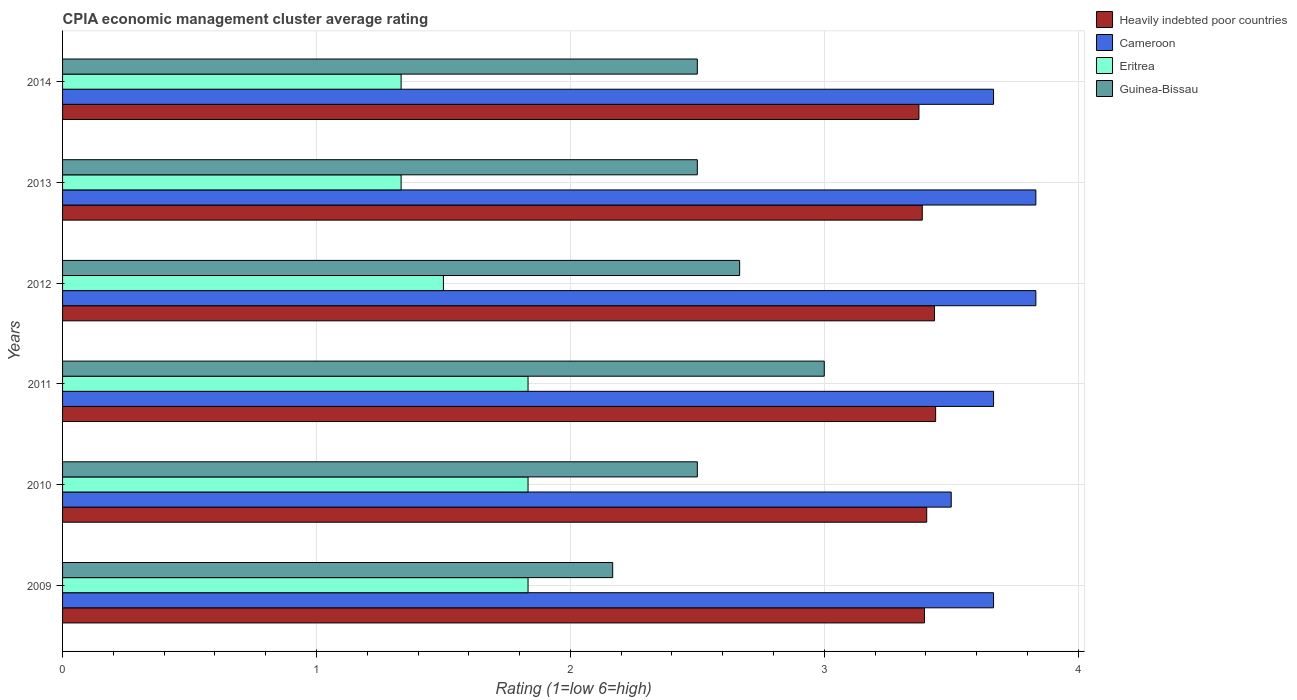How many groups of bars are there?
Provide a succinct answer. 6. How many bars are there on the 5th tick from the top?
Keep it short and to the point. 4. How many bars are there on the 5th tick from the bottom?
Keep it short and to the point. 4. What is the label of the 5th group of bars from the top?
Provide a succinct answer. 2010. In how many cases, is the number of bars for a given year not equal to the number of legend labels?
Keep it short and to the point. 0. What is the CPIA rating in Guinea-Bissau in 2010?
Make the answer very short. 2.5. Across all years, what is the maximum CPIA rating in Heavily indebted poor countries?
Ensure brevity in your answer.  3.44. Across all years, what is the minimum CPIA rating in Cameroon?
Your response must be concise. 3.5. In which year was the CPIA rating in Eritrea minimum?
Ensure brevity in your answer.  2014. What is the total CPIA rating in Cameroon in the graph?
Your answer should be compact. 22.17. What is the difference between the CPIA rating in Guinea-Bissau in 2009 and that in 2012?
Offer a terse response. -0.5. What is the difference between the CPIA rating in Cameroon in 2009 and the CPIA rating in Eritrea in 2012?
Offer a very short reply. 2.17. What is the average CPIA rating in Cameroon per year?
Your answer should be very brief. 3.69. What is the ratio of the CPIA rating in Guinea-Bissau in 2012 to that in 2013?
Provide a succinct answer. 1.07. Is the CPIA rating in Cameroon in 2012 less than that in 2013?
Your answer should be very brief. No. Is the difference between the CPIA rating in Guinea-Bissau in 2012 and 2013 greater than the difference between the CPIA rating in Cameroon in 2012 and 2013?
Offer a terse response. Yes. What is the difference between the highest and the lowest CPIA rating in Cameroon?
Offer a terse response. 0.33. Is the sum of the CPIA rating in Cameroon in 2010 and 2014 greater than the maximum CPIA rating in Heavily indebted poor countries across all years?
Provide a short and direct response. Yes. Is it the case that in every year, the sum of the CPIA rating in Cameroon and CPIA rating in Guinea-Bissau is greater than the sum of CPIA rating in Eritrea and CPIA rating in Heavily indebted poor countries?
Provide a short and direct response. No. What does the 2nd bar from the top in 2009 represents?
Keep it short and to the point. Eritrea. What does the 4th bar from the bottom in 2012 represents?
Offer a terse response. Guinea-Bissau. Is it the case that in every year, the sum of the CPIA rating in Heavily indebted poor countries and CPIA rating in Eritrea is greater than the CPIA rating in Cameroon?
Provide a short and direct response. Yes. How many bars are there?
Provide a succinct answer. 24. How many years are there in the graph?
Give a very brief answer. 6. Are the values on the major ticks of X-axis written in scientific E-notation?
Ensure brevity in your answer.  No. Does the graph contain any zero values?
Ensure brevity in your answer.  No. How are the legend labels stacked?
Your answer should be very brief. Vertical. What is the title of the graph?
Keep it short and to the point. CPIA economic management cluster average rating. What is the label or title of the X-axis?
Provide a succinct answer. Rating (1=low 6=high). What is the Rating (1=low 6=high) in Heavily indebted poor countries in 2009?
Provide a short and direct response. 3.39. What is the Rating (1=low 6=high) in Cameroon in 2009?
Offer a very short reply. 3.67. What is the Rating (1=low 6=high) in Eritrea in 2009?
Offer a terse response. 1.83. What is the Rating (1=low 6=high) in Guinea-Bissau in 2009?
Offer a terse response. 2.17. What is the Rating (1=low 6=high) in Heavily indebted poor countries in 2010?
Your response must be concise. 3.4. What is the Rating (1=low 6=high) of Cameroon in 2010?
Your response must be concise. 3.5. What is the Rating (1=low 6=high) of Eritrea in 2010?
Give a very brief answer. 1.83. What is the Rating (1=low 6=high) in Heavily indebted poor countries in 2011?
Offer a very short reply. 3.44. What is the Rating (1=low 6=high) of Cameroon in 2011?
Give a very brief answer. 3.67. What is the Rating (1=low 6=high) in Eritrea in 2011?
Your response must be concise. 1.83. What is the Rating (1=low 6=high) in Heavily indebted poor countries in 2012?
Your response must be concise. 3.43. What is the Rating (1=low 6=high) in Cameroon in 2012?
Provide a succinct answer. 3.83. What is the Rating (1=low 6=high) in Eritrea in 2012?
Provide a short and direct response. 1.5. What is the Rating (1=low 6=high) of Guinea-Bissau in 2012?
Offer a terse response. 2.67. What is the Rating (1=low 6=high) of Heavily indebted poor countries in 2013?
Make the answer very short. 3.39. What is the Rating (1=low 6=high) in Cameroon in 2013?
Ensure brevity in your answer.  3.83. What is the Rating (1=low 6=high) in Eritrea in 2013?
Offer a terse response. 1.33. What is the Rating (1=low 6=high) in Heavily indebted poor countries in 2014?
Your answer should be very brief. 3.37. What is the Rating (1=low 6=high) of Cameroon in 2014?
Give a very brief answer. 3.67. What is the Rating (1=low 6=high) in Eritrea in 2014?
Your answer should be compact. 1.33. Across all years, what is the maximum Rating (1=low 6=high) of Heavily indebted poor countries?
Your answer should be very brief. 3.44. Across all years, what is the maximum Rating (1=low 6=high) in Cameroon?
Keep it short and to the point. 3.83. Across all years, what is the maximum Rating (1=low 6=high) in Eritrea?
Give a very brief answer. 1.83. Across all years, what is the maximum Rating (1=low 6=high) in Guinea-Bissau?
Give a very brief answer. 3. Across all years, what is the minimum Rating (1=low 6=high) in Heavily indebted poor countries?
Ensure brevity in your answer.  3.37. Across all years, what is the minimum Rating (1=low 6=high) in Eritrea?
Give a very brief answer. 1.33. Across all years, what is the minimum Rating (1=low 6=high) of Guinea-Bissau?
Your answer should be very brief. 2.17. What is the total Rating (1=low 6=high) in Heavily indebted poor countries in the graph?
Give a very brief answer. 20.43. What is the total Rating (1=low 6=high) of Cameroon in the graph?
Your answer should be very brief. 22.17. What is the total Rating (1=low 6=high) in Eritrea in the graph?
Provide a short and direct response. 9.67. What is the total Rating (1=low 6=high) in Guinea-Bissau in the graph?
Your answer should be very brief. 15.33. What is the difference between the Rating (1=low 6=high) in Heavily indebted poor countries in 2009 and that in 2010?
Keep it short and to the point. -0.01. What is the difference between the Rating (1=low 6=high) in Heavily indebted poor countries in 2009 and that in 2011?
Provide a short and direct response. -0.04. What is the difference between the Rating (1=low 6=high) of Eritrea in 2009 and that in 2011?
Your answer should be very brief. 0. What is the difference between the Rating (1=low 6=high) of Heavily indebted poor countries in 2009 and that in 2012?
Give a very brief answer. -0.04. What is the difference between the Rating (1=low 6=high) of Cameroon in 2009 and that in 2012?
Provide a succinct answer. -0.17. What is the difference between the Rating (1=low 6=high) in Heavily indebted poor countries in 2009 and that in 2013?
Your response must be concise. 0.01. What is the difference between the Rating (1=low 6=high) of Cameroon in 2009 and that in 2013?
Your answer should be compact. -0.17. What is the difference between the Rating (1=low 6=high) in Guinea-Bissau in 2009 and that in 2013?
Ensure brevity in your answer.  -0.33. What is the difference between the Rating (1=low 6=high) in Heavily indebted poor countries in 2009 and that in 2014?
Offer a very short reply. 0.02. What is the difference between the Rating (1=low 6=high) in Cameroon in 2009 and that in 2014?
Your answer should be very brief. 0. What is the difference between the Rating (1=low 6=high) of Guinea-Bissau in 2009 and that in 2014?
Offer a terse response. -0.33. What is the difference between the Rating (1=low 6=high) of Heavily indebted poor countries in 2010 and that in 2011?
Make the answer very short. -0.04. What is the difference between the Rating (1=low 6=high) in Eritrea in 2010 and that in 2011?
Provide a succinct answer. 0. What is the difference between the Rating (1=low 6=high) of Guinea-Bissau in 2010 and that in 2011?
Give a very brief answer. -0.5. What is the difference between the Rating (1=low 6=high) in Heavily indebted poor countries in 2010 and that in 2012?
Offer a very short reply. -0.03. What is the difference between the Rating (1=low 6=high) of Heavily indebted poor countries in 2010 and that in 2013?
Your answer should be compact. 0.02. What is the difference between the Rating (1=low 6=high) in Guinea-Bissau in 2010 and that in 2013?
Your response must be concise. 0. What is the difference between the Rating (1=low 6=high) of Heavily indebted poor countries in 2010 and that in 2014?
Provide a succinct answer. 0.03. What is the difference between the Rating (1=low 6=high) of Cameroon in 2010 and that in 2014?
Provide a succinct answer. -0.17. What is the difference between the Rating (1=low 6=high) in Heavily indebted poor countries in 2011 and that in 2012?
Your answer should be very brief. 0. What is the difference between the Rating (1=low 6=high) in Cameroon in 2011 and that in 2012?
Give a very brief answer. -0.17. What is the difference between the Rating (1=low 6=high) in Guinea-Bissau in 2011 and that in 2012?
Offer a terse response. 0.33. What is the difference between the Rating (1=low 6=high) in Heavily indebted poor countries in 2011 and that in 2013?
Offer a very short reply. 0.05. What is the difference between the Rating (1=low 6=high) in Guinea-Bissau in 2011 and that in 2013?
Provide a short and direct response. 0.5. What is the difference between the Rating (1=low 6=high) in Heavily indebted poor countries in 2011 and that in 2014?
Make the answer very short. 0.07. What is the difference between the Rating (1=low 6=high) of Heavily indebted poor countries in 2012 and that in 2013?
Your response must be concise. 0.05. What is the difference between the Rating (1=low 6=high) in Eritrea in 2012 and that in 2013?
Keep it short and to the point. 0.17. What is the difference between the Rating (1=low 6=high) in Heavily indebted poor countries in 2012 and that in 2014?
Ensure brevity in your answer.  0.06. What is the difference between the Rating (1=low 6=high) in Cameroon in 2012 and that in 2014?
Keep it short and to the point. 0.17. What is the difference between the Rating (1=low 6=high) of Eritrea in 2012 and that in 2014?
Provide a short and direct response. 0.17. What is the difference between the Rating (1=low 6=high) of Guinea-Bissau in 2012 and that in 2014?
Offer a very short reply. 0.17. What is the difference between the Rating (1=low 6=high) of Heavily indebted poor countries in 2013 and that in 2014?
Your answer should be compact. 0.01. What is the difference between the Rating (1=low 6=high) of Cameroon in 2013 and that in 2014?
Keep it short and to the point. 0.17. What is the difference between the Rating (1=low 6=high) of Guinea-Bissau in 2013 and that in 2014?
Offer a terse response. 0. What is the difference between the Rating (1=low 6=high) of Heavily indebted poor countries in 2009 and the Rating (1=low 6=high) of Cameroon in 2010?
Provide a short and direct response. -0.11. What is the difference between the Rating (1=low 6=high) of Heavily indebted poor countries in 2009 and the Rating (1=low 6=high) of Eritrea in 2010?
Give a very brief answer. 1.56. What is the difference between the Rating (1=low 6=high) of Heavily indebted poor countries in 2009 and the Rating (1=low 6=high) of Guinea-Bissau in 2010?
Ensure brevity in your answer.  0.89. What is the difference between the Rating (1=low 6=high) of Cameroon in 2009 and the Rating (1=low 6=high) of Eritrea in 2010?
Your answer should be very brief. 1.83. What is the difference between the Rating (1=low 6=high) of Cameroon in 2009 and the Rating (1=low 6=high) of Guinea-Bissau in 2010?
Ensure brevity in your answer.  1.17. What is the difference between the Rating (1=low 6=high) of Heavily indebted poor countries in 2009 and the Rating (1=low 6=high) of Cameroon in 2011?
Make the answer very short. -0.27. What is the difference between the Rating (1=low 6=high) in Heavily indebted poor countries in 2009 and the Rating (1=low 6=high) in Eritrea in 2011?
Offer a terse response. 1.56. What is the difference between the Rating (1=low 6=high) of Heavily indebted poor countries in 2009 and the Rating (1=low 6=high) of Guinea-Bissau in 2011?
Keep it short and to the point. 0.39. What is the difference between the Rating (1=low 6=high) of Cameroon in 2009 and the Rating (1=low 6=high) of Eritrea in 2011?
Ensure brevity in your answer.  1.83. What is the difference between the Rating (1=low 6=high) of Eritrea in 2009 and the Rating (1=low 6=high) of Guinea-Bissau in 2011?
Keep it short and to the point. -1.17. What is the difference between the Rating (1=low 6=high) of Heavily indebted poor countries in 2009 and the Rating (1=low 6=high) of Cameroon in 2012?
Provide a short and direct response. -0.44. What is the difference between the Rating (1=low 6=high) in Heavily indebted poor countries in 2009 and the Rating (1=low 6=high) in Eritrea in 2012?
Your answer should be compact. 1.89. What is the difference between the Rating (1=low 6=high) of Heavily indebted poor countries in 2009 and the Rating (1=low 6=high) of Guinea-Bissau in 2012?
Provide a short and direct response. 0.73. What is the difference between the Rating (1=low 6=high) in Cameroon in 2009 and the Rating (1=low 6=high) in Eritrea in 2012?
Ensure brevity in your answer.  2.17. What is the difference between the Rating (1=low 6=high) of Eritrea in 2009 and the Rating (1=low 6=high) of Guinea-Bissau in 2012?
Your answer should be compact. -0.83. What is the difference between the Rating (1=low 6=high) of Heavily indebted poor countries in 2009 and the Rating (1=low 6=high) of Cameroon in 2013?
Your response must be concise. -0.44. What is the difference between the Rating (1=low 6=high) of Heavily indebted poor countries in 2009 and the Rating (1=low 6=high) of Eritrea in 2013?
Make the answer very short. 2.06. What is the difference between the Rating (1=low 6=high) in Heavily indebted poor countries in 2009 and the Rating (1=low 6=high) in Guinea-Bissau in 2013?
Make the answer very short. 0.89. What is the difference between the Rating (1=low 6=high) in Cameroon in 2009 and the Rating (1=low 6=high) in Eritrea in 2013?
Provide a succinct answer. 2.33. What is the difference between the Rating (1=low 6=high) in Eritrea in 2009 and the Rating (1=low 6=high) in Guinea-Bissau in 2013?
Provide a succinct answer. -0.67. What is the difference between the Rating (1=low 6=high) of Heavily indebted poor countries in 2009 and the Rating (1=low 6=high) of Cameroon in 2014?
Provide a short and direct response. -0.27. What is the difference between the Rating (1=low 6=high) of Heavily indebted poor countries in 2009 and the Rating (1=low 6=high) of Eritrea in 2014?
Make the answer very short. 2.06. What is the difference between the Rating (1=low 6=high) of Heavily indebted poor countries in 2009 and the Rating (1=low 6=high) of Guinea-Bissau in 2014?
Give a very brief answer. 0.89. What is the difference between the Rating (1=low 6=high) in Cameroon in 2009 and the Rating (1=low 6=high) in Eritrea in 2014?
Provide a short and direct response. 2.33. What is the difference between the Rating (1=low 6=high) in Eritrea in 2009 and the Rating (1=low 6=high) in Guinea-Bissau in 2014?
Ensure brevity in your answer.  -0.67. What is the difference between the Rating (1=low 6=high) in Heavily indebted poor countries in 2010 and the Rating (1=low 6=high) in Cameroon in 2011?
Offer a very short reply. -0.26. What is the difference between the Rating (1=low 6=high) in Heavily indebted poor countries in 2010 and the Rating (1=low 6=high) in Eritrea in 2011?
Offer a very short reply. 1.57. What is the difference between the Rating (1=low 6=high) in Heavily indebted poor countries in 2010 and the Rating (1=low 6=high) in Guinea-Bissau in 2011?
Offer a very short reply. 0.4. What is the difference between the Rating (1=low 6=high) of Cameroon in 2010 and the Rating (1=low 6=high) of Guinea-Bissau in 2011?
Give a very brief answer. 0.5. What is the difference between the Rating (1=low 6=high) of Eritrea in 2010 and the Rating (1=low 6=high) of Guinea-Bissau in 2011?
Ensure brevity in your answer.  -1.17. What is the difference between the Rating (1=low 6=high) in Heavily indebted poor countries in 2010 and the Rating (1=low 6=high) in Cameroon in 2012?
Your response must be concise. -0.43. What is the difference between the Rating (1=low 6=high) in Heavily indebted poor countries in 2010 and the Rating (1=low 6=high) in Eritrea in 2012?
Provide a short and direct response. 1.9. What is the difference between the Rating (1=low 6=high) of Heavily indebted poor countries in 2010 and the Rating (1=low 6=high) of Guinea-Bissau in 2012?
Keep it short and to the point. 0.74. What is the difference between the Rating (1=low 6=high) in Eritrea in 2010 and the Rating (1=low 6=high) in Guinea-Bissau in 2012?
Give a very brief answer. -0.83. What is the difference between the Rating (1=low 6=high) of Heavily indebted poor countries in 2010 and the Rating (1=low 6=high) of Cameroon in 2013?
Provide a succinct answer. -0.43. What is the difference between the Rating (1=low 6=high) of Heavily indebted poor countries in 2010 and the Rating (1=low 6=high) of Eritrea in 2013?
Your answer should be compact. 2.07. What is the difference between the Rating (1=low 6=high) in Heavily indebted poor countries in 2010 and the Rating (1=low 6=high) in Guinea-Bissau in 2013?
Your answer should be very brief. 0.9. What is the difference between the Rating (1=low 6=high) of Cameroon in 2010 and the Rating (1=low 6=high) of Eritrea in 2013?
Your response must be concise. 2.17. What is the difference between the Rating (1=low 6=high) in Cameroon in 2010 and the Rating (1=low 6=high) in Guinea-Bissau in 2013?
Your answer should be compact. 1. What is the difference between the Rating (1=low 6=high) of Heavily indebted poor countries in 2010 and the Rating (1=low 6=high) of Cameroon in 2014?
Keep it short and to the point. -0.26. What is the difference between the Rating (1=low 6=high) of Heavily indebted poor countries in 2010 and the Rating (1=low 6=high) of Eritrea in 2014?
Offer a terse response. 2.07. What is the difference between the Rating (1=low 6=high) in Heavily indebted poor countries in 2010 and the Rating (1=low 6=high) in Guinea-Bissau in 2014?
Keep it short and to the point. 0.9. What is the difference between the Rating (1=low 6=high) of Cameroon in 2010 and the Rating (1=low 6=high) of Eritrea in 2014?
Offer a terse response. 2.17. What is the difference between the Rating (1=low 6=high) in Eritrea in 2010 and the Rating (1=low 6=high) in Guinea-Bissau in 2014?
Give a very brief answer. -0.67. What is the difference between the Rating (1=low 6=high) of Heavily indebted poor countries in 2011 and the Rating (1=low 6=high) of Cameroon in 2012?
Your answer should be very brief. -0.39. What is the difference between the Rating (1=low 6=high) of Heavily indebted poor countries in 2011 and the Rating (1=low 6=high) of Eritrea in 2012?
Give a very brief answer. 1.94. What is the difference between the Rating (1=low 6=high) in Heavily indebted poor countries in 2011 and the Rating (1=low 6=high) in Guinea-Bissau in 2012?
Offer a terse response. 0.77. What is the difference between the Rating (1=low 6=high) in Cameroon in 2011 and the Rating (1=low 6=high) in Eritrea in 2012?
Your response must be concise. 2.17. What is the difference between the Rating (1=low 6=high) in Eritrea in 2011 and the Rating (1=low 6=high) in Guinea-Bissau in 2012?
Your response must be concise. -0.83. What is the difference between the Rating (1=low 6=high) of Heavily indebted poor countries in 2011 and the Rating (1=low 6=high) of Cameroon in 2013?
Your answer should be very brief. -0.39. What is the difference between the Rating (1=low 6=high) in Heavily indebted poor countries in 2011 and the Rating (1=low 6=high) in Eritrea in 2013?
Offer a very short reply. 2.11. What is the difference between the Rating (1=low 6=high) in Heavily indebted poor countries in 2011 and the Rating (1=low 6=high) in Guinea-Bissau in 2013?
Provide a short and direct response. 0.94. What is the difference between the Rating (1=low 6=high) of Cameroon in 2011 and the Rating (1=low 6=high) of Eritrea in 2013?
Keep it short and to the point. 2.33. What is the difference between the Rating (1=low 6=high) in Cameroon in 2011 and the Rating (1=low 6=high) in Guinea-Bissau in 2013?
Offer a terse response. 1.17. What is the difference between the Rating (1=low 6=high) in Eritrea in 2011 and the Rating (1=low 6=high) in Guinea-Bissau in 2013?
Give a very brief answer. -0.67. What is the difference between the Rating (1=low 6=high) in Heavily indebted poor countries in 2011 and the Rating (1=low 6=high) in Cameroon in 2014?
Provide a succinct answer. -0.23. What is the difference between the Rating (1=low 6=high) of Heavily indebted poor countries in 2011 and the Rating (1=low 6=high) of Eritrea in 2014?
Make the answer very short. 2.11. What is the difference between the Rating (1=low 6=high) in Heavily indebted poor countries in 2011 and the Rating (1=low 6=high) in Guinea-Bissau in 2014?
Provide a short and direct response. 0.94. What is the difference between the Rating (1=low 6=high) of Cameroon in 2011 and the Rating (1=low 6=high) of Eritrea in 2014?
Your answer should be very brief. 2.33. What is the difference between the Rating (1=low 6=high) in Heavily indebted poor countries in 2012 and the Rating (1=low 6=high) in Cameroon in 2013?
Your answer should be compact. -0.4. What is the difference between the Rating (1=low 6=high) in Heavily indebted poor countries in 2012 and the Rating (1=low 6=high) in Eritrea in 2013?
Your response must be concise. 2.1. What is the difference between the Rating (1=low 6=high) in Heavily indebted poor countries in 2012 and the Rating (1=low 6=high) in Guinea-Bissau in 2013?
Offer a terse response. 0.93. What is the difference between the Rating (1=low 6=high) of Cameroon in 2012 and the Rating (1=low 6=high) of Eritrea in 2013?
Provide a succinct answer. 2.5. What is the difference between the Rating (1=low 6=high) of Cameroon in 2012 and the Rating (1=low 6=high) of Guinea-Bissau in 2013?
Give a very brief answer. 1.33. What is the difference between the Rating (1=low 6=high) of Heavily indebted poor countries in 2012 and the Rating (1=low 6=high) of Cameroon in 2014?
Offer a terse response. -0.23. What is the difference between the Rating (1=low 6=high) of Heavily indebted poor countries in 2012 and the Rating (1=low 6=high) of Eritrea in 2014?
Offer a very short reply. 2.1. What is the difference between the Rating (1=low 6=high) of Heavily indebted poor countries in 2012 and the Rating (1=low 6=high) of Guinea-Bissau in 2014?
Provide a succinct answer. 0.93. What is the difference between the Rating (1=low 6=high) of Eritrea in 2012 and the Rating (1=low 6=high) of Guinea-Bissau in 2014?
Give a very brief answer. -1. What is the difference between the Rating (1=low 6=high) in Heavily indebted poor countries in 2013 and the Rating (1=low 6=high) in Cameroon in 2014?
Provide a succinct answer. -0.28. What is the difference between the Rating (1=low 6=high) of Heavily indebted poor countries in 2013 and the Rating (1=low 6=high) of Eritrea in 2014?
Provide a short and direct response. 2.05. What is the difference between the Rating (1=low 6=high) in Heavily indebted poor countries in 2013 and the Rating (1=low 6=high) in Guinea-Bissau in 2014?
Provide a succinct answer. 0.89. What is the difference between the Rating (1=low 6=high) in Cameroon in 2013 and the Rating (1=low 6=high) in Guinea-Bissau in 2014?
Your answer should be compact. 1.33. What is the difference between the Rating (1=low 6=high) in Eritrea in 2013 and the Rating (1=low 6=high) in Guinea-Bissau in 2014?
Give a very brief answer. -1.17. What is the average Rating (1=low 6=high) of Heavily indebted poor countries per year?
Your answer should be compact. 3.4. What is the average Rating (1=low 6=high) of Cameroon per year?
Keep it short and to the point. 3.69. What is the average Rating (1=low 6=high) in Eritrea per year?
Keep it short and to the point. 1.61. What is the average Rating (1=low 6=high) in Guinea-Bissau per year?
Provide a succinct answer. 2.56. In the year 2009, what is the difference between the Rating (1=low 6=high) of Heavily indebted poor countries and Rating (1=low 6=high) of Cameroon?
Offer a terse response. -0.27. In the year 2009, what is the difference between the Rating (1=low 6=high) of Heavily indebted poor countries and Rating (1=low 6=high) of Eritrea?
Your answer should be very brief. 1.56. In the year 2009, what is the difference between the Rating (1=low 6=high) in Heavily indebted poor countries and Rating (1=low 6=high) in Guinea-Bissau?
Provide a succinct answer. 1.23. In the year 2009, what is the difference between the Rating (1=low 6=high) of Cameroon and Rating (1=low 6=high) of Eritrea?
Your answer should be very brief. 1.83. In the year 2009, what is the difference between the Rating (1=low 6=high) of Eritrea and Rating (1=low 6=high) of Guinea-Bissau?
Offer a terse response. -0.33. In the year 2010, what is the difference between the Rating (1=low 6=high) in Heavily indebted poor countries and Rating (1=low 6=high) in Cameroon?
Your answer should be very brief. -0.1. In the year 2010, what is the difference between the Rating (1=low 6=high) in Heavily indebted poor countries and Rating (1=low 6=high) in Eritrea?
Your answer should be very brief. 1.57. In the year 2010, what is the difference between the Rating (1=low 6=high) of Heavily indebted poor countries and Rating (1=low 6=high) of Guinea-Bissau?
Make the answer very short. 0.9. In the year 2010, what is the difference between the Rating (1=low 6=high) of Cameroon and Rating (1=low 6=high) of Guinea-Bissau?
Offer a very short reply. 1. In the year 2010, what is the difference between the Rating (1=low 6=high) in Eritrea and Rating (1=low 6=high) in Guinea-Bissau?
Your answer should be compact. -0.67. In the year 2011, what is the difference between the Rating (1=low 6=high) in Heavily indebted poor countries and Rating (1=low 6=high) in Cameroon?
Make the answer very short. -0.23. In the year 2011, what is the difference between the Rating (1=low 6=high) of Heavily indebted poor countries and Rating (1=low 6=high) of Eritrea?
Keep it short and to the point. 1.61. In the year 2011, what is the difference between the Rating (1=low 6=high) of Heavily indebted poor countries and Rating (1=low 6=high) of Guinea-Bissau?
Provide a succinct answer. 0.44. In the year 2011, what is the difference between the Rating (1=low 6=high) in Cameroon and Rating (1=low 6=high) in Eritrea?
Offer a terse response. 1.83. In the year 2011, what is the difference between the Rating (1=low 6=high) of Eritrea and Rating (1=low 6=high) of Guinea-Bissau?
Keep it short and to the point. -1.17. In the year 2012, what is the difference between the Rating (1=low 6=high) in Heavily indebted poor countries and Rating (1=low 6=high) in Cameroon?
Ensure brevity in your answer.  -0.4. In the year 2012, what is the difference between the Rating (1=low 6=high) of Heavily indebted poor countries and Rating (1=low 6=high) of Eritrea?
Keep it short and to the point. 1.93. In the year 2012, what is the difference between the Rating (1=low 6=high) in Heavily indebted poor countries and Rating (1=low 6=high) in Guinea-Bissau?
Give a very brief answer. 0.77. In the year 2012, what is the difference between the Rating (1=low 6=high) of Cameroon and Rating (1=low 6=high) of Eritrea?
Ensure brevity in your answer.  2.33. In the year 2012, what is the difference between the Rating (1=low 6=high) in Cameroon and Rating (1=low 6=high) in Guinea-Bissau?
Provide a short and direct response. 1.17. In the year 2012, what is the difference between the Rating (1=low 6=high) in Eritrea and Rating (1=low 6=high) in Guinea-Bissau?
Your answer should be compact. -1.17. In the year 2013, what is the difference between the Rating (1=low 6=high) in Heavily indebted poor countries and Rating (1=low 6=high) in Cameroon?
Your answer should be very brief. -0.45. In the year 2013, what is the difference between the Rating (1=low 6=high) in Heavily indebted poor countries and Rating (1=low 6=high) in Eritrea?
Your answer should be compact. 2.05. In the year 2013, what is the difference between the Rating (1=low 6=high) in Heavily indebted poor countries and Rating (1=low 6=high) in Guinea-Bissau?
Provide a succinct answer. 0.89. In the year 2013, what is the difference between the Rating (1=low 6=high) of Cameroon and Rating (1=low 6=high) of Eritrea?
Your response must be concise. 2.5. In the year 2013, what is the difference between the Rating (1=low 6=high) in Eritrea and Rating (1=low 6=high) in Guinea-Bissau?
Your answer should be very brief. -1.17. In the year 2014, what is the difference between the Rating (1=low 6=high) in Heavily indebted poor countries and Rating (1=low 6=high) in Cameroon?
Provide a succinct answer. -0.29. In the year 2014, what is the difference between the Rating (1=low 6=high) in Heavily indebted poor countries and Rating (1=low 6=high) in Eritrea?
Your answer should be very brief. 2.04. In the year 2014, what is the difference between the Rating (1=low 6=high) of Heavily indebted poor countries and Rating (1=low 6=high) of Guinea-Bissau?
Ensure brevity in your answer.  0.87. In the year 2014, what is the difference between the Rating (1=low 6=high) of Cameroon and Rating (1=low 6=high) of Eritrea?
Offer a very short reply. 2.33. In the year 2014, what is the difference between the Rating (1=low 6=high) in Eritrea and Rating (1=low 6=high) in Guinea-Bissau?
Provide a succinct answer. -1.17. What is the ratio of the Rating (1=low 6=high) in Heavily indebted poor countries in 2009 to that in 2010?
Ensure brevity in your answer.  1. What is the ratio of the Rating (1=low 6=high) in Cameroon in 2009 to that in 2010?
Make the answer very short. 1.05. What is the ratio of the Rating (1=low 6=high) of Guinea-Bissau in 2009 to that in 2010?
Provide a short and direct response. 0.87. What is the ratio of the Rating (1=low 6=high) of Heavily indebted poor countries in 2009 to that in 2011?
Provide a short and direct response. 0.99. What is the ratio of the Rating (1=low 6=high) of Cameroon in 2009 to that in 2011?
Offer a terse response. 1. What is the ratio of the Rating (1=low 6=high) of Eritrea in 2009 to that in 2011?
Offer a very short reply. 1. What is the ratio of the Rating (1=low 6=high) of Guinea-Bissau in 2009 to that in 2011?
Make the answer very short. 0.72. What is the ratio of the Rating (1=low 6=high) of Cameroon in 2009 to that in 2012?
Offer a very short reply. 0.96. What is the ratio of the Rating (1=low 6=high) in Eritrea in 2009 to that in 2012?
Keep it short and to the point. 1.22. What is the ratio of the Rating (1=low 6=high) of Guinea-Bissau in 2009 to that in 2012?
Provide a short and direct response. 0.81. What is the ratio of the Rating (1=low 6=high) in Cameroon in 2009 to that in 2013?
Keep it short and to the point. 0.96. What is the ratio of the Rating (1=low 6=high) of Eritrea in 2009 to that in 2013?
Offer a very short reply. 1.38. What is the ratio of the Rating (1=low 6=high) in Guinea-Bissau in 2009 to that in 2013?
Offer a terse response. 0.87. What is the ratio of the Rating (1=low 6=high) in Heavily indebted poor countries in 2009 to that in 2014?
Keep it short and to the point. 1.01. What is the ratio of the Rating (1=low 6=high) in Eritrea in 2009 to that in 2014?
Offer a terse response. 1.38. What is the ratio of the Rating (1=low 6=high) in Guinea-Bissau in 2009 to that in 2014?
Make the answer very short. 0.87. What is the ratio of the Rating (1=low 6=high) of Heavily indebted poor countries in 2010 to that in 2011?
Keep it short and to the point. 0.99. What is the ratio of the Rating (1=low 6=high) of Cameroon in 2010 to that in 2011?
Your answer should be compact. 0.95. What is the ratio of the Rating (1=low 6=high) in Eritrea in 2010 to that in 2011?
Give a very brief answer. 1. What is the ratio of the Rating (1=low 6=high) of Eritrea in 2010 to that in 2012?
Offer a terse response. 1.22. What is the ratio of the Rating (1=low 6=high) of Eritrea in 2010 to that in 2013?
Your response must be concise. 1.38. What is the ratio of the Rating (1=low 6=high) in Guinea-Bissau in 2010 to that in 2013?
Offer a very short reply. 1. What is the ratio of the Rating (1=low 6=high) in Heavily indebted poor countries in 2010 to that in 2014?
Provide a short and direct response. 1.01. What is the ratio of the Rating (1=low 6=high) in Cameroon in 2010 to that in 2014?
Give a very brief answer. 0.95. What is the ratio of the Rating (1=low 6=high) in Eritrea in 2010 to that in 2014?
Provide a succinct answer. 1.38. What is the ratio of the Rating (1=low 6=high) of Heavily indebted poor countries in 2011 to that in 2012?
Keep it short and to the point. 1. What is the ratio of the Rating (1=low 6=high) of Cameroon in 2011 to that in 2012?
Your answer should be very brief. 0.96. What is the ratio of the Rating (1=low 6=high) of Eritrea in 2011 to that in 2012?
Make the answer very short. 1.22. What is the ratio of the Rating (1=low 6=high) of Guinea-Bissau in 2011 to that in 2012?
Your answer should be very brief. 1.12. What is the ratio of the Rating (1=low 6=high) in Heavily indebted poor countries in 2011 to that in 2013?
Provide a short and direct response. 1.02. What is the ratio of the Rating (1=low 6=high) in Cameroon in 2011 to that in 2013?
Ensure brevity in your answer.  0.96. What is the ratio of the Rating (1=low 6=high) of Eritrea in 2011 to that in 2013?
Provide a short and direct response. 1.38. What is the ratio of the Rating (1=low 6=high) of Guinea-Bissau in 2011 to that in 2013?
Provide a short and direct response. 1.2. What is the ratio of the Rating (1=low 6=high) in Heavily indebted poor countries in 2011 to that in 2014?
Your answer should be very brief. 1.02. What is the ratio of the Rating (1=low 6=high) in Cameroon in 2011 to that in 2014?
Your response must be concise. 1. What is the ratio of the Rating (1=low 6=high) of Eritrea in 2011 to that in 2014?
Keep it short and to the point. 1.38. What is the ratio of the Rating (1=low 6=high) of Heavily indebted poor countries in 2012 to that in 2013?
Your answer should be compact. 1.01. What is the ratio of the Rating (1=low 6=high) of Eritrea in 2012 to that in 2013?
Offer a terse response. 1.12. What is the ratio of the Rating (1=low 6=high) in Guinea-Bissau in 2012 to that in 2013?
Give a very brief answer. 1.07. What is the ratio of the Rating (1=low 6=high) in Heavily indebted poor countries in 2012 to that in 2014?
Your answer should be very brief. 1.02. What is the ratio of the Rating (1=low 6=high) in Cameroon in 2012 to that in 2014?
Offer a very short reply. 1.05. What is the ratio of the Rating (1=low 6=high) of Guinea-Bissau in 2012 to that in 2014?
Give a very brief answer. 1.07. What is the ratio of the Rating (1=low 6=high) in Heavily indebted poor countries in 2013 to that in 2014?
Give a very brief answer. 1. What is the ratio of the Rating (1=low 6=high) of Cameroon in 2013 to that in 2014?
Offer a terse response. 1.05. What is the ratio of the Rating (1=low 6=high) of Eritrea in 2013 to that in 2014?
Provide a short and direct response. 1. What is the difference between the highest and the second highest Rating (1=low 6=high) in Heavily indebted poor countries?
Your answer should be compact. 0. What is the difference between the highest and the second highest Rating (1=low 6=high) in Guinea-Bissau?
Keep it short and to the point. 0.33. What is the difference between the highest and the lowest Rating (1=low 6=high) of Heavily indebted poor countries?
Your response must be concise. 0.07. What is the difference between the highest and the lowest Rating (1=low 6=high) in Eritrea?
Your answer should be very brief. 0.5. 